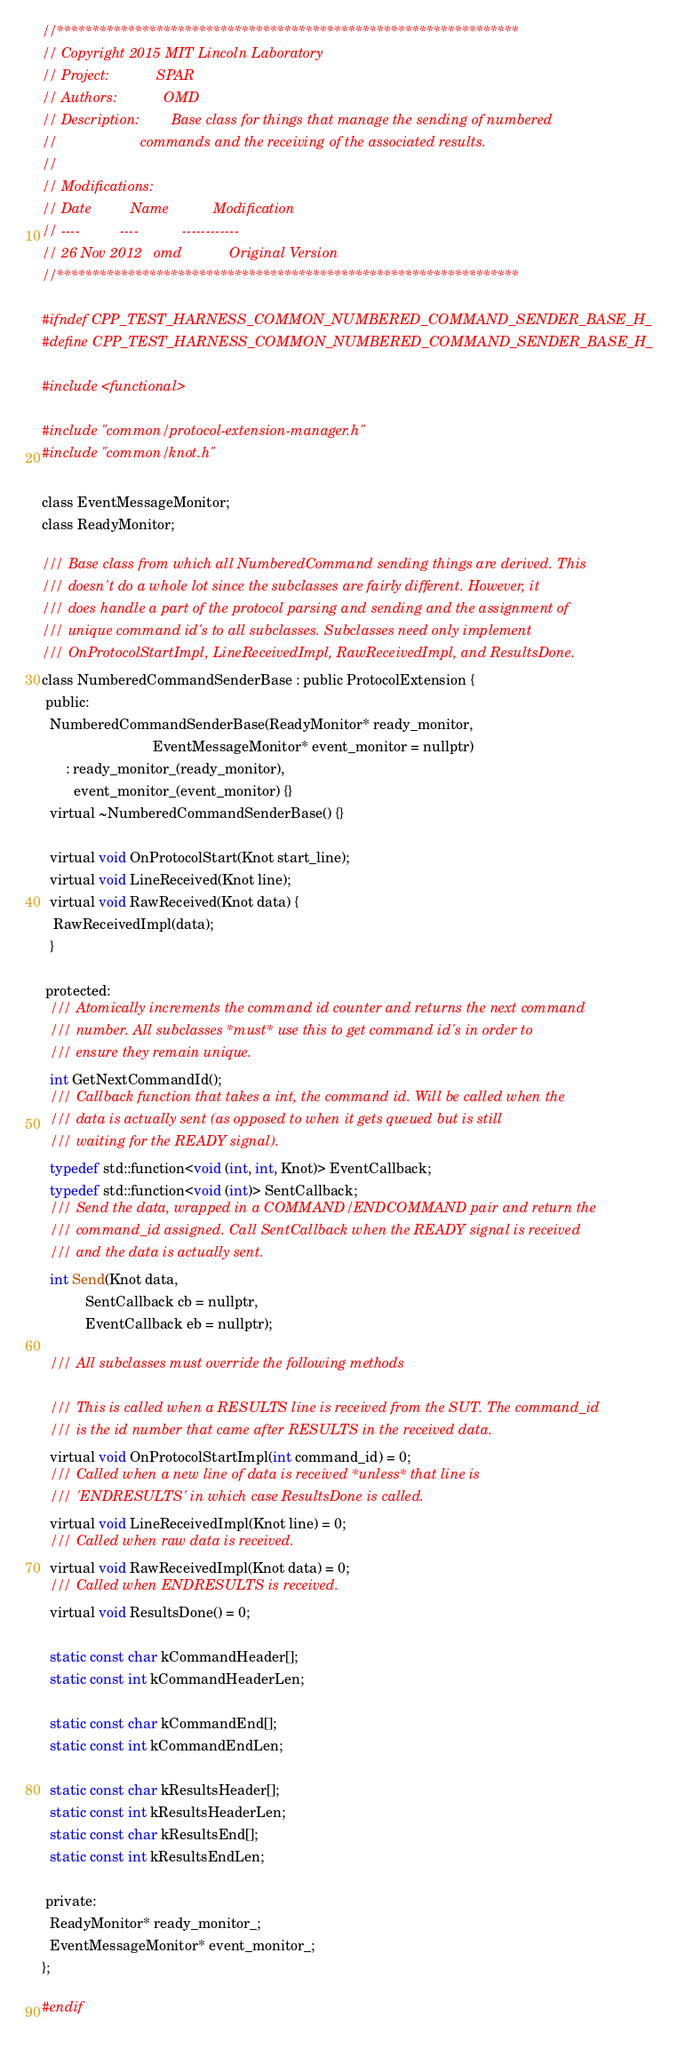<code> <loc_0><loc_0><loc_500><loc_500><_C_>//*****************************************************************
// Copyright 2015 MIT Lincoln Laboratory  
// Project:            SPAR
// Authors:            OMD
// Description:        Base class for things that manage the sending of numbered
//                     commands and the receiving of the associated results. 
//
// Modifications:
// Date          Name           Modification
// ----          ----           ------------
// 26 Nov 2012   omd            Original Version
//*****************************************************************

#ifndef CPP_TEST_HARNESS_COMMON_NUMBERED_COMMAND_SENDER_BASE_H_
#define CPP_TEST_HARNESS_COMMON_NUMBERED_COMMAND_SENDER_BASE_H_

#include <functional>

#include "common/protocol-extension-manager.h"
#include "common/knot.h"

class EventMessageMonitor;
class ReadyMonitor;

/// Base class from which all NumberedCommand sending things are derived. This
/// doesn't do a whole lot since the subclasses are fairly different. However, it
/// does handle a part of the protocol parsing and sending and the assignment of
/// unique command id's to all subclasses. Subclasses need only implement
/// OnProtocolStartImpl, LineReceivedImpl, RawReceivedImpl, and ResultsDone.
class NumberedCommandSenderBase : public ProtocolExtension {
 public:
  NumberedCommandSenderBase(ReadyMonitor* ready_monitor,
                            EventMessageMonitor* event_monitor = nullptr)
      : ready_monitor_(ready_monitor),
        event_monitor_(event_monitor) {}
  virtual ~NumberedCommandSenderBase() {}

  virtual void OnProtocolStart(Knot start_line);
  virtual void LineReceived(Knot line);
  virtual void RawReceived(Knot data) {
   RawReceivedImpl(data);
  } 

 protected:
  /// Atomically increments the command id counter and returns the next command
  /// number. All subclasses *must* use this to get command id's in order to
  /// ensure they remain unique.
  int GetNextCommandId();
  /// Callback function that takes a int, the command id. Will be called when the
  /// data is actually sent (as opposed to when it gets queued but is still
  /// waiting for the READY signal).
  typedef std::function<void (int, int, Knot)> EventCallback;
  typedef std::function<void (int)> SentCallback;
  /// Send the data, wrapped in a COMMAND/ENDCOMMAND pair and return the
  /// command_id assigned. Call SentCallback when the READY signal is received
  /// and the data is actually sent.
  int Send(Knot data, 
           SentCallback cb = nullptr, 
           EventCallback eb = nullptr);

  /// All subclasses must override the following methods

  /// This is called when a RESULTS line is received from the SUT. The command_id
  /// is the id number that came after RESULTS in the received data.
  virtual void OnProtocolStartImpl(int command_id) = 0;
  /// Called when a new line of data is received *unless* that line is
  /// 'ENDRESULTS' in which case ResultsDone is called.
  virtual void LineReceivedImpl(Knot line) = 0;
  /// Called when raw data is received.
  virtual void RawReceivedImpl(Knot data) = 0;
  /// Called when ENDRESULTS is received.
  virtual void ResultsDone() = 0;

  static const char kCommandHeader[];
  static const int kCommandHeaderLen;

  static const char kCommandEnd[];
  static const int kCommandEndLen;

  static const char kResultsHeader[];
  static const int kResultsHeaderLen;
  static const char kResultsEnd[];
  static const int kResultsEndLen;

 private:
  ReadyMonitor* ready_monitor_;
  EventMessageMonitor* event_monitor_;
};

#endif
</code> 